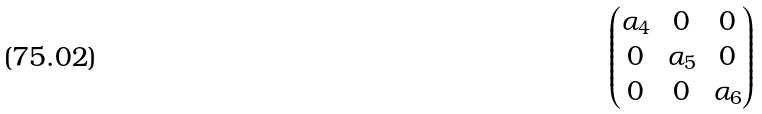Convert formula to latex. <formula><loc_0><loc_0><loc_500><loc_500>\begin{pmatrix} \alpha _ { 4 } & 0 & 0 \\ 0 & \alpha _ { 5 } & 0 \\ 0 & 0 & \alpha _ { 6 } \\ \end{pmatrix}</formula> 